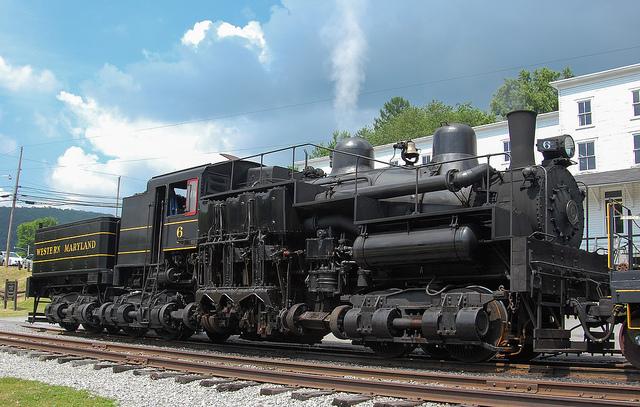Is this train for royalties?
Short answer required. No. Is this picture in color?
Keep it brief. Yes. Is this a modern train?
Be succinct. No. Is it dangerous standing where the picture was taken?
Quick response, please. No. Is this a plane?
Short answer required. No. What color is the smoke coming from the top of the train?
Quick response, please. White. What numbers are on the train?
Keep it brief. 6. Is this train still in use?
Keep it brief. Yes. How many cars does the train have?
Keep it brief. 1. What is the item to the left of the train?
Be succinct. Car. What is beneath the train tracks?
Short answer required. Gravel. Is there white smoke?
Be succinct. Yes. 